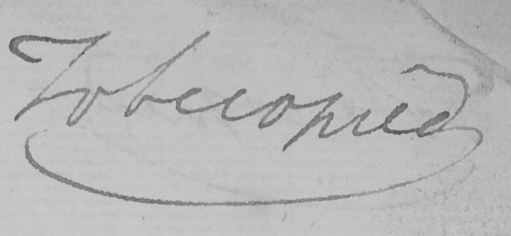What does this handwritten line say? To be copied 